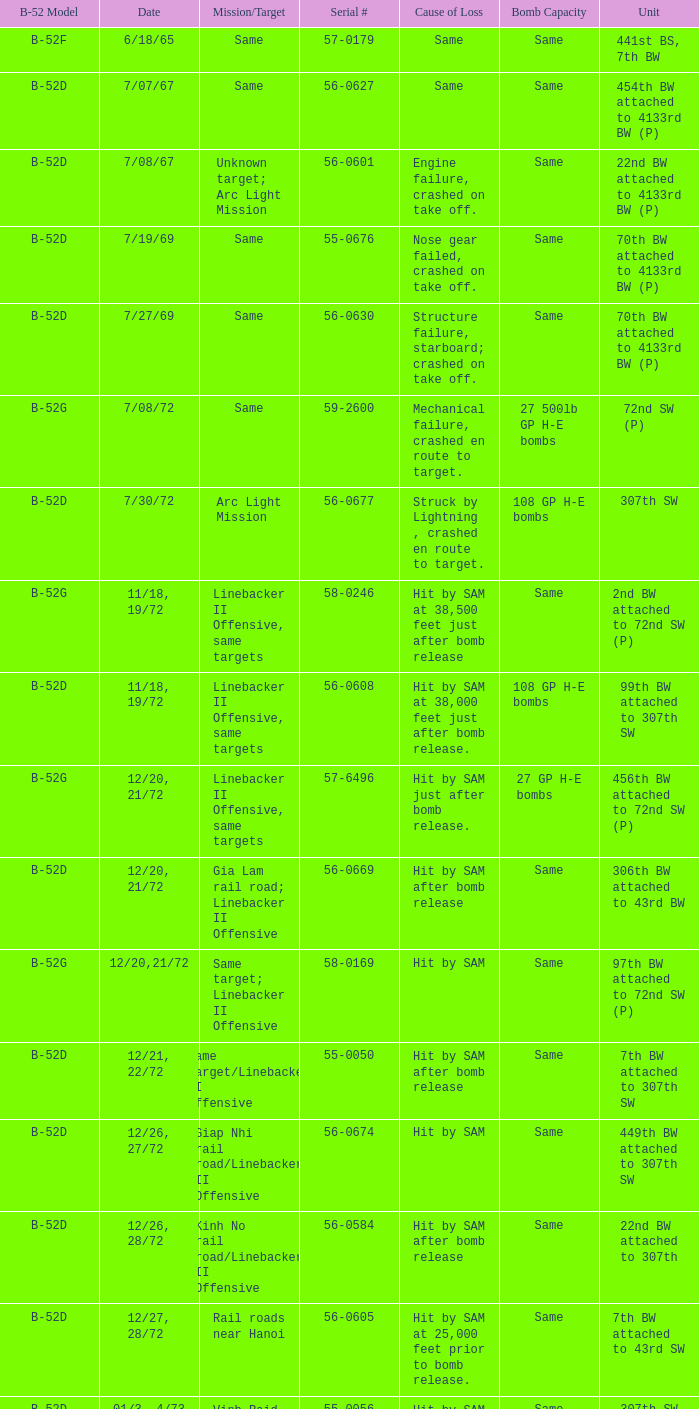I'm looking to parse the entire table for insights. Could you assist me with that? {'header': ['B-52 Model', 'Date', 'Mission/Target', 'Serial #', 'Cause of Loss', 'Bomb Capacity', 'Unit'], 'rows': [['B-52F', '6/18/65', 'Same', '57-0179', 'Same', 'Same', '441st BS, 7th BW'], ['B-52D', '7/07/67', 'Same', '56-0627', 'Same', 'Same', '454th BW attached to 4133rd BW (P)'], ['B-52D', '7/08/67', 'Unknown target; Arc Light Mission', '56-0601', 'Engine failure, crashed on take off.', 'Same', '22nd BW attached to 4133rd BW (P)'], ['B-52D', '7/19/69', 'Same', '55-0676', 'Nose gear failed, crashed on take off.', 'Same', '70th BW attached to 4133rd BW (P)'], ['B-52D', '7/27/69', 'Same', '56-0630', 'Structure failure, starboard; crashed on take off.', 'Same', '70th BW attached to 4133rd BW (P)'], ['B-52G', '7/08/72', 'Same', '59-2600', 'Mechanical failure, crashed en route to target.', '27 500lb GP H-E bombs', '72nd SW (P)'], ['B-52D', '7/30/72', 'Arc Light Mission', '56-0677', 'Struck by Lightning , crashed en route to target.', '108 GP H-E bombs', '307th SW'], ['B-52G', '11/18, 19/72', 'Linebacker II Offensive, same targets', '58-0246', 'Hit by SAM at 38,500 feet just after bomb release', 'Same', '2nd BW attached to 72nd SW (P)'], ['B-52D', '11/18, 19/72', 'Linebacker II Offensive, same targets', '56-0608', 'Hit by SAM at 38,000 feet just after bomb release.', '108 GP H-E bombs', '99th BW attached to 307th SW'], ['B-52G', '12/20, 21/72', 'Linebacker II Offensive, same targets', '57-6496', 'Hit by SAM just after bomb release.', '27 GP H-E bombs', '456th BW attached to 72nd SW (P)'], ['B-52D', '12/20, 21/72', 'Gia Lam rail road; Linebacker II Offensive', '56-0669', 'Hit by SAM after bomb release', 'Same', '306th BW attached to 43rd BW'], ['B-52G', '12/20,21/72', 'Same target; Linebacker II Offensive', '58-0169', 'Hit by SAM', 'Same', '97th BW attached to 72nd SW (P)'], ['B-52D', '12/21, 22/72', 'Same target/Linebacker II Offensive', '55-0050', 'Hit by SAM after bomb release', 'Same', '7th BW attached to 307th SW'], ['B-52D', '12/26, 27/72', 'Giap Nhi rail road/Linebacker II Offensive', '56-0674', 'Hit by SAM', 'Same', '449th BW attached to 307th SW'], ['B-52D', '12/26, 28/72', 'Kinh No rail road/Linebacker II Offensive', '56-0584', 'Hit by SAM after bomb release', 'Same', '22nd BW attached to 307th'], ['B-52D', '12/27, 28/72', 'Rail roads near Hanoi', '56-0605', 'Hit by SAM at 25,000 feet prior to bomb release.', 'Same', '7th BW attached to 43rd SW'], ['B-52D', '01/3, 4/73', 'Vinh Raid, North Vietnam', '55-0056', 'Hit by SAM during bomb release.', 'Same', '307th SW']]} When hit by sam at 38,500 feet just after bomb release was the cause of loss what is the mission/target? Linebacker II Offensive, same targets. 